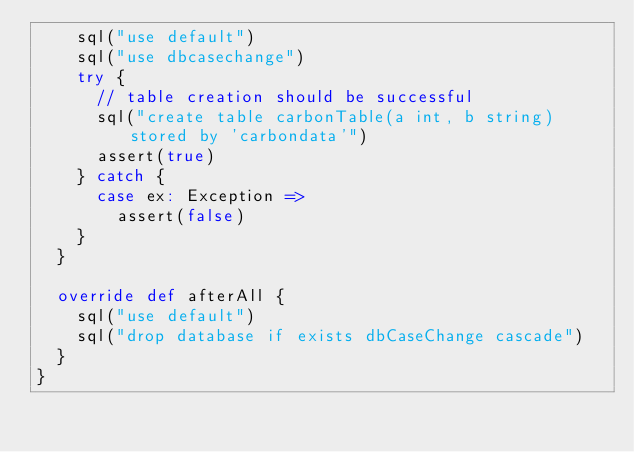Convert code to text. <code><loc_0><loc_0><loc_500><loc_500><_Scala_>    sql("use default")
    sql("use dbcasechange")
    try {
      // table creation should be successful
      sql("create table carbonTable(a int, b string)stored by 'carbondata'")
      assert(true)
    } catch {
      case ex: Exception =>
        assert(false)
    }
  }

  override def afterAll {
    sql("use default")
    sql("drop database if exists dbCaseChange cascade")
  }
}
</code> 